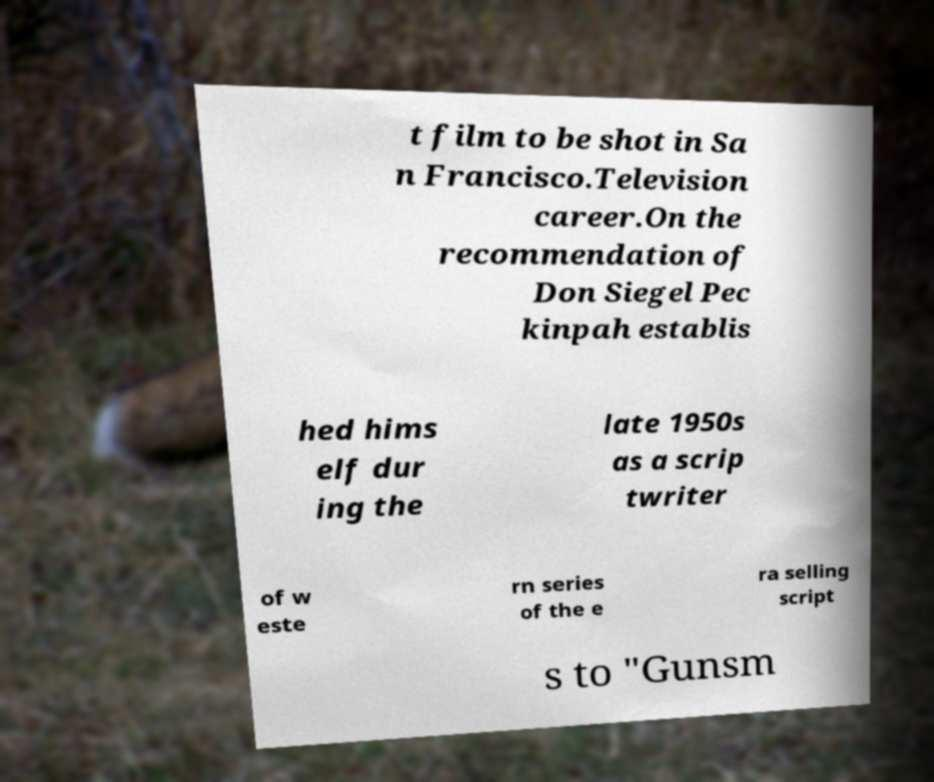Please identify and transcribe the text found in this image. t film to be shot in Sa n Francisco.Television career.On the recommendation of Don Siegel Pec kinpah establis hed hims elf dur ing the late 1950s as a scrip twriter of w este rn series of the e ra selling script s to "Gunsm 